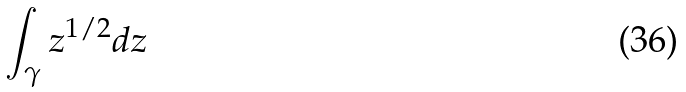Convert formula to latex. <formula><loc_0><loc_0><loc_500><loc_500>\int _ { \gamma } z ^ { 1 / 2 } d z</formula> 